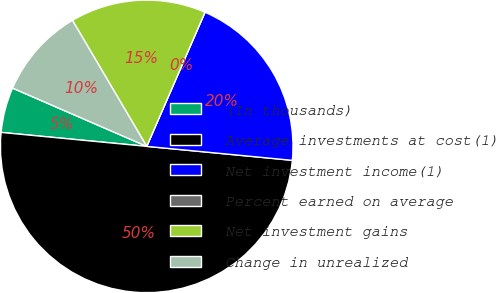Convert chart to OTSL. <chart><loc_0><loc_0><loc_500><loc_500><pie_chart><fcel>(In thousands)<fcel>Average investments at cost(1)<fcel>Net investment income(1)<fcel>Percent earned on average<fcel>Net investment gains<fcel>Change in unrealized<nl><fcel>5.0%<fcel>50.0%<fcel>20.0%<fcel>0.0%<fcel>15.0%<fcel>10.0%<nl></chart> 